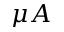<formula> <loc_0><loc_0><loc_500><loc_500>\mu A</formula> 